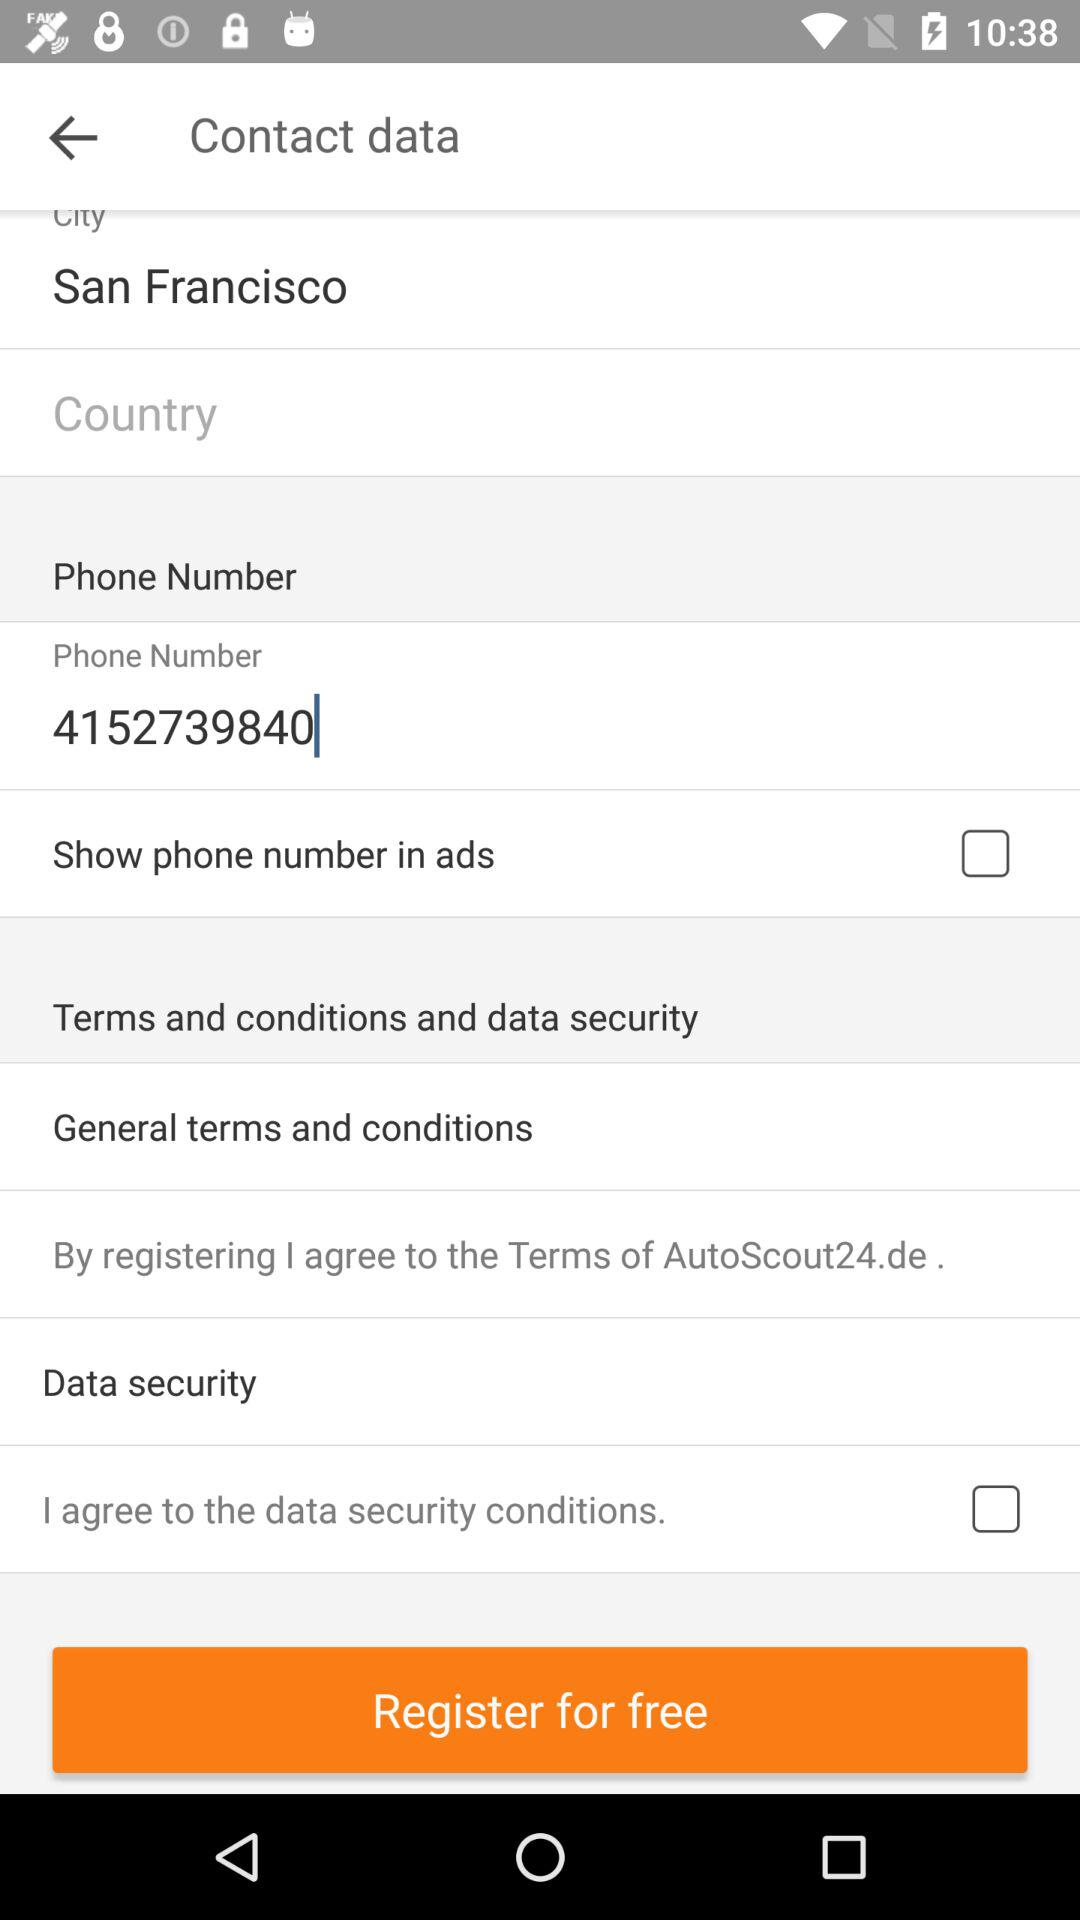How many text inputs are there that are not empty?
Answer the question using a single word or phrase. 2 